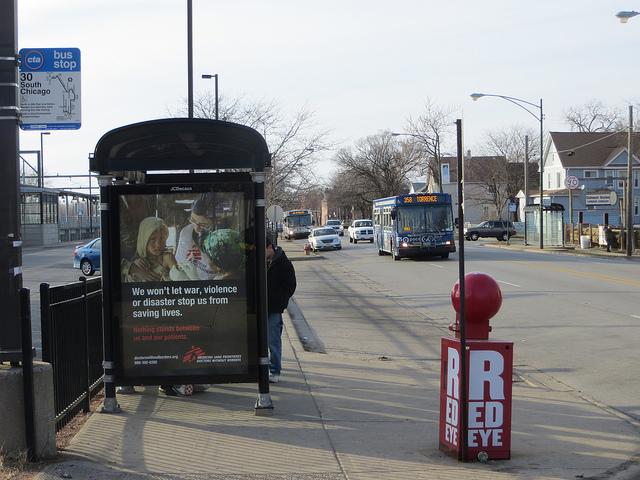Are there any people on the sidewalk?
Quick response, please. Yes. In what city is this photo taken?
Give a very brief answer. Chicago. Is the bus being driven?
Short answer required. Yes. 